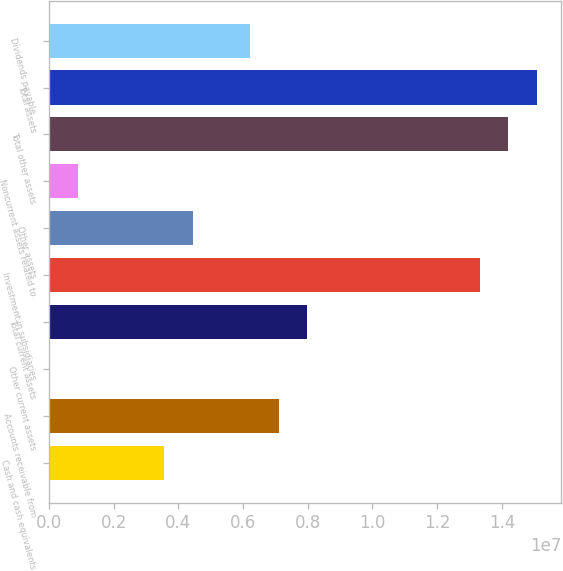Convert chart. <chart><loc_0><loc_0><loc_500><loc_500><bar_chart><fcel>Cash and cash equivalents<fcel>Accounts receivable from<fcel>Other current assets<fcel>Total current assets<fcel>Investment in subsidiaries<fcel>Other assets<fcel>Noncurrent assets related to<fcel>Total other assets<fcel>Total assets<fcel>Dividends payable<nl><fcel>3.55435e+06<fcel>7.10213e+06<fcel>6573<fcel>7.98908e+06<fcel>1.33107e+07<fcel>4.4413e+06<fcel>893518<fcel>1.41977e+07<fcel>1.50846e+07<fcel>6.21519e+06<nl></chart> 